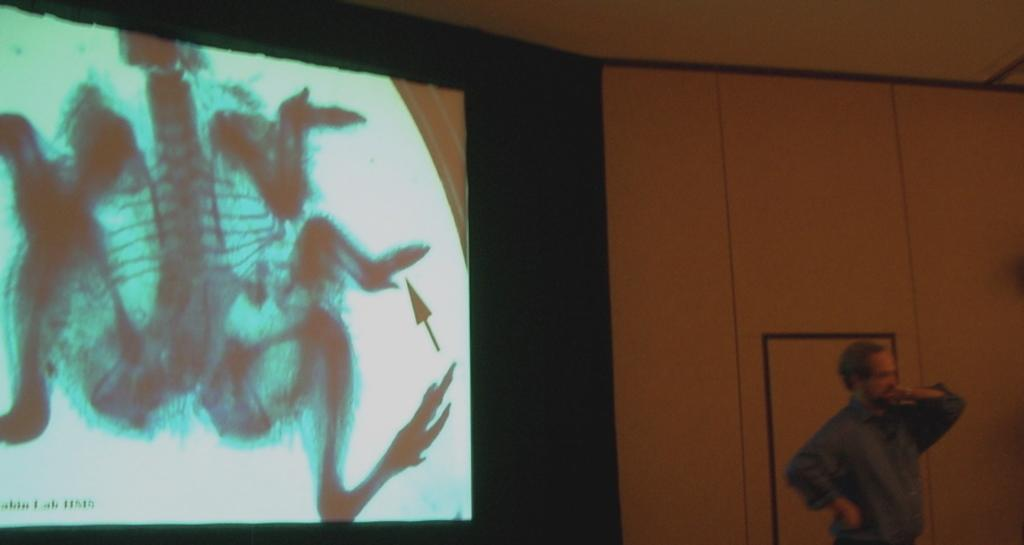What is the main subject in the image? There is a person standing in the image. What is the person standing in front of? There is a projection screen in the image. What else can be seen in the background of the image? There is a wall in the image. What type of car is parked next to the person in the image? There is no car present in the image; it only features a person, a projection screen, and a wall. 